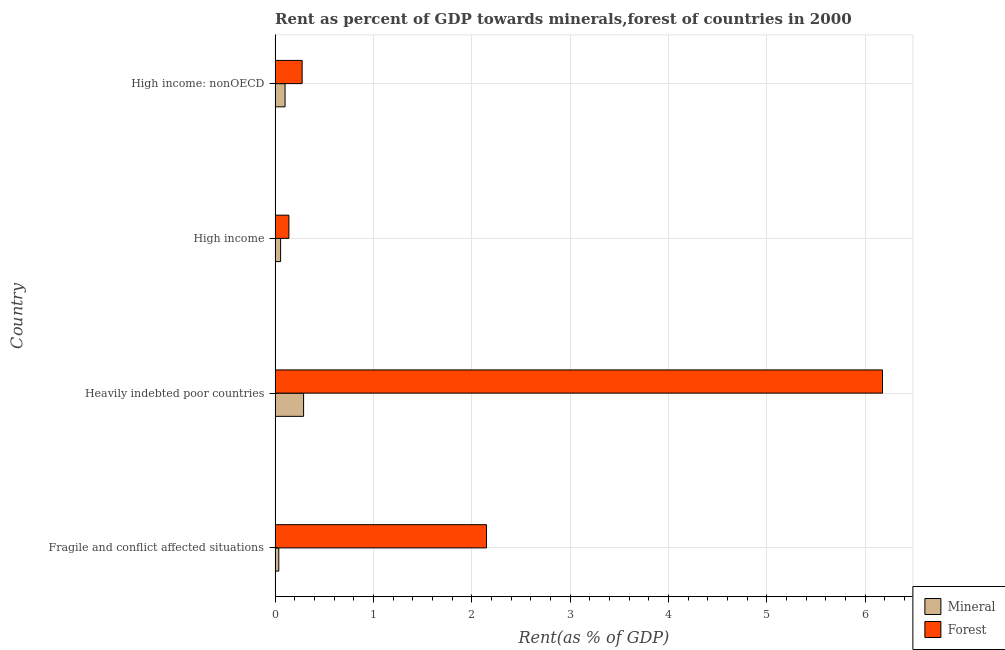How many groups of bars are there?
Keep it short and to the point. 4. How many bars are there on the 3rd tick from the top?
Offer a terse response. 2. What is the label of the 4th group of bars from the top?
Your answer should be compact. Fragile and conflict affected situations. What is the forest rent in High income: nonOECD?
Your response must be concise. 0.28. Across all countries, what is the maximum mineral rent?
Your response must be concise. 0.29. Across all countries, what is the minimum mineral rent?
Your answer should be compact. 0.04. In which country was the mineral rent maximum?
Give a very brief answer. Heavily indebted poor countries. In which country was the mineral rent minimum?
Give a very brief answer. Fragile and conflict affected situations. What is the total forest rent in the graph?
Provide a short and direct response. 8.74. What is the difference between the forest rent in High income and that in High income: nonOECD?
Make the answer very short. -0.14. What is the difference between the mineral rent in High income and the forest rent in High income: nonOECD?
Your answer should be compact. -0.22. What is the average mineral rent per country?
Provide a short and direct response. 0.12. What is the difference between the forest rent and mineral rent in High income?
Provide a short and direct response. 0.08. What is the ratio of the forest rent in High income to that in High income: nonOECD?
Keep it short and to the point. 0.51. What is the difference between the highest and the second highest mineral rent?
Offer a terse response. 0.19. What is the difference between the highest and the lowest forest rent?
Your answer should be very brief. 6.03. What does the 2nd bar from the top in High income represents?
Keep it short and to the point. Mineral. What does the 2nd bar from the bottom in Fragile and conflict affected situations represents?
Make the answer very short. Forest. How many bars are there?
Your response must be concise. 8. Are all the bars in the graph horizontal?
Ensure brevity in your answer.  Yes. Does the graph contain grids?
Give a very brief answer. Yes. How many legend labels are there?
Ensure brevity in your answer.  2. What is the title of the graph?
Provide a succinct answer. Rent as percent of GDP towards minerals,forest of countries in 2000. Does "External balance on goods" appear as one of the legend labels in the graph?
Give a very brief answer. No. What is the label or title of the X-axis?
Provide a short and direct response. Rent(as % of GDP). What is the label or title of the Y-axis?
Your response must be concise. Country. What is the Rent(as % of GDP) of Mineral in Fragile and conflict affected situations?
Offer a terse response. 0.04. What is the Rent(as % of GDP) in Forest in Fragile and conflict affected situations?
Keep it short and to the point. 2.15. What is the Rent(as % of GDP) of Mineral in Heavily indebted poor countries?
Offer a terse response. 0.29. What is the Rent(as % of GDP) of Forest in Heavily indebted poor countries?
Your answer should be compact. 6.17. What is the Rent(as % of GDP) in Mineral in High income?
Ensure brevity in your answer.  0.06. What is the Rent(as % of GDP) in Forest in High income?
Keep it short and to the point. 0.14. What is the Rent(as % of GDP) of Mineral in High income: nonOECD?
Your answer should be very brief. 0.1. What is the Rent(as % of GDP) of Forest in High income: nonOECD?
Your answer should be very brief. 0.28. Across all countries, what is the maximum Rent(as % of GDP) in Mineral?
Keep it short and to the point. 0.29. Across all countries, what is the maximum Rent(as % of GDP) in Forest?
Offer a very short reply. 6.17. Across all countries, what is the minimum Rent(as % of GDP) of Mineral?
Your answer should be compact. 0.04. Across all countries, what is the minimum Rent(as % of GDP) in Forest?
Make the answer very short. 0.14. What is the total Rent(as % of GDP) of Mineral in the graph?
Your answer should be very brief. 0.49. What is the total Rent(as % of GDP) of Forest in the graph?
Make the answer very short. 8.74. What is the difference between the Rent(as % of GDP) in Mineral in Fragile and conflict affected situations and that in Heavily indebted poor countries?
Offer a terse response. -0.25. What is the difference between the Rent(as % of GDP) in Forest in Fragile and conflict affected situations and that in Heavily indebted poor countries?
Offer a terse response. -4.03. What is the difference between the Rent(as % of GDP) in Mineral in Fragile and conflict affected situations and that in High income?
Keep it short and to the point. -0.02. What is the difference between the Rent(as % of GDP) in Forest in Fragile and conflict affected situations and that in High income?
Offer a very short reply. 2.01. What is the difference between the Rent(as % of GDP) in Mineral in Fragile and conflict affected situations and that in High income: nonOECD?
Your answer should be very brief. -0.06. What is the difference between the Rent(as % of GDP) in Forest in Fragile and conflict affected situations and that in High income: nonOECD?
Provide a short and direct response. 1.87. What is the difference between the Rent(as % of GDP) in Mineral in Heavily indebted poor countries and that in High income?
Ensure brevity in your answer.  0.23. What is the difference between the Rent(as % of GDP) of Forest in Heavily indebted poor countries and that in High income?
Your response must be concise. 6.03. What is the difference between the Rent(as % of GDP) of Mineral in Heavily indebted poor countries and that in High income: nonOECD?
Give a very brief answer. 0.19. What is the difference between the Rent(as % of GDP) in Forest in Heavily indebted poor countries and that in High income: nonOECD?
Make the answer very short. 5.9. What is the difference between the Rent(as % of GDP) of Mineral in High income and that in High income: nonOECD?
Provide a short and direct response. -0.05. What is the difference between the Rent(as % of GDP) in Forest in High income and that in High income: nonOECD?
Offer a terse response. -0.13. What is the difference between the Rent(as % of GDP) in Mineral in Fragile and conflict affected situations and the Rent(as % of GDP) in Forest in Heavily indebted poor countries?
Offer a terse response. -6.14. What is the difference between the Rent(as % of GDP) of Mineral in Fragile and conflict affected situations and the Rent(as % of GDP) of Forest in High income?
Give a very brief answer. -0.1. What is the difference between the Rent(as % of GDP) of Mineral in Fragile and conflict affected situations and the Rent(as % of GDP) of Forest in High income: nonOECD?
Keep it short and to the point. -0.24. What is the difference between the Rent(as % of GDP) of Mineral in Heavily indebted poor countries and the Rent(as % of GDP) of Forest in High income?
Ensure brevity in your answer.  0.15. What is the difference between the Rent(as % of GDP) in Mineral in Heavily indebted poor countries and the Rent(as % of GDP) in Forest in High income: nonOECD?
Offer a very short reply. 0.01. What is the difference between the Rent(as % of GDP) in Mineral in High income and the Rent(as % of GDP) in Forest in High income: nonOECD?
Ensure brevity in your answer.  -0.22. What is the average Rent(as % of GDP) in Mineral per country?
Make the answer very short. 0.12. What is the average Rent(as % of GDP) in Forest per country?
Provide a succinct answer. 2.18. What is the difference between the Rent(as % of GDP) of Mineral and Rent(as % of GDP) of Forest in Fragile and conflict affected situations?
Ensure brevity in your answer.  -2.11. What is the difference between the Rent(as % of GDP) of Mineral and Rent(as % of GDP) of Forest in Heavily indebted poor countries?
Your answer should be very brief. -5.88. What is the difference between the Rent(as % of GDP) in Mineral and Rent(as % of GDP) in Forest in High income?
Offer a terse response. -0.08. What is the difference between the Rent(as % of GDP) in Mineral and Rent(as % of GDP) in Forest in High income: nonOECD?
Provide a short and direct response. -0.17. What is the ratio of the Rent(as % of GDP) in Mineral in Fragile and conflict affected situations to that in Heavily indebted poor countries?
Ensure brevity in your answer.  0.13. What is the ratio of the Rent(as % of GDP) of Forest in Fragile and conflict affected situations to that in Heavily indebted poor countries?
Give a very brief answer. 0.35. What is the ratio of the Rent(as % of GDP) in Mineral in Fragile and conflict affected situations to that in High income?
Offer a very short reply. 0.67. What is the ratio of the Rent(as % of GDP) of Forest in Fragile and conflict affected situations to that in High income?
Ensure brevity in your answer.  15.29. What is the ratio of the Rent(as % of GDP) in Mineral in Fragile and conflict affected situations to that in High income: nonOECD?
Ensure brevity in your answer.  0.37. What is the ratio of the Rent(as % of GDP) in Forest in Fragile and conflict affected situations to that in High income: nonOECD?
Keep it short and to the point. 7.81. What is the ratio of the Rent(as % of GDP) in Mineral in Heavily indebted poor countries to that in High income?
Give a very brief answer. 5.16. What is the ratio of the Rent(as % of GDP) in Forest in Heavily indebted poor countries to that in High income?
Ensure brevity in your answer.  43.93. What is the ratio of the Rent(as % of GDP) of Mineral in Heavily indebted poor countries to that in High income: nonOECD?
Ensure brevity in your answer.  2.86. What is the ratio of the Rent(as % of GDP) in Forest in Heavily indebted poor countries to that in High income: nonOECD?
Ensure brevity in your answer.  22.45. What is the ratio of the Rent(as % of GDP) in Mineral in High income to that in High income: nonOECD?
Offer a terse response. 0.55. What is the ratio of the Rent(as % of GDP) in Forest in High income to that in High income: nonOECD?
Give a very brief answer. 0.51. What is the difference between the highest and the second highest Rent(as % of GDP) of Mineral?
Ensure brevity in your answer.  0.19. What is the difference between the highest and the second highest Rent(as % of GDP) in Forest?
Keep it short and to the point. 4.03. What is the difference between the highest and the lowest Rent(as % of GDP) in Mineral?
Your answer should be compact. 0.25. What is the difference between the highest and the lowest Rent(as % of GDP) of Forest?
Your response must be concise. 6.03. 